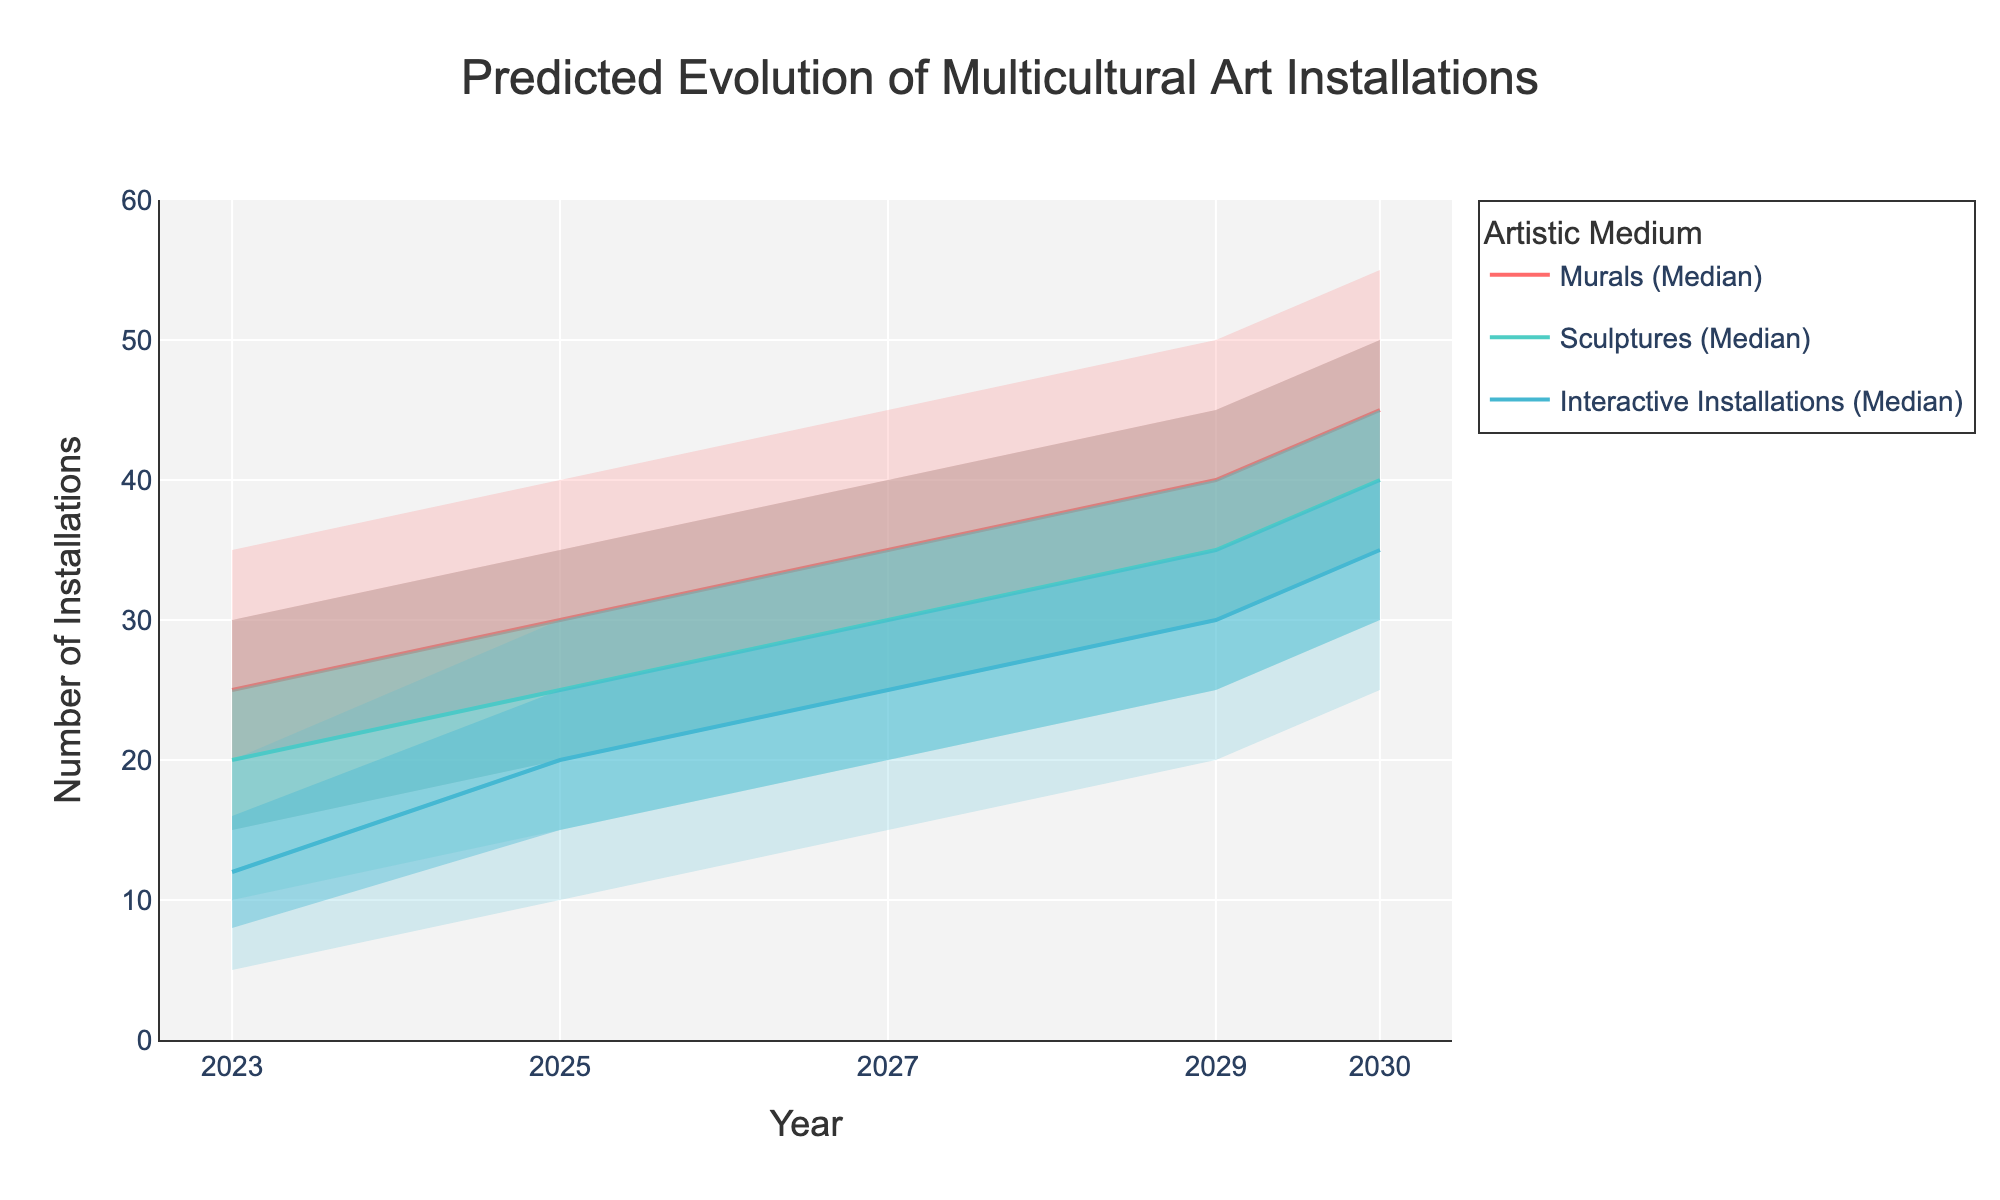What's the title of the figure? The title is usually located at the top of the figure. In this case, based on the provided code, we know the title is 'Predicted Evolution of Multicultural Art Installations.'
Answer: Predicted Evolution of Multicultural Art Installations Which medium shows the highest median number of installations in 2023? By looking at the median values for each medium in 2023, we see that Murals have a median of 25, Sculptures have 20, and Interactive Installations have 12. Thus, Murals have the highest median.
Answer: Murals What is the range of predicted installations for Sculptures in 2025? The range can be determined by subtracting the lower bound from the upper bound for Sculptures in 2025, which is 35 - 15.
Answer: 20 How do the upper quartile values of Murals and Sculptures compare in 2027? In 2027, the upper quartile for Murals is 40, and for Sculptures, it is 35. Therefore, the upper quartile for Murals is higher.
Answer: Murals have a higher upper quartile What is the expected increase in the median number of Interactive Installations from 2023 to 2030? The median number of installations for Interactive Installations in 2023 is 12 and in 2030 is 35. The increase is 35 - 12.
Answer: 23 Which medium has the widest interquartile range (IQR) in 2029? The IQR is calculated as the upper quartile minus the lower quartile. For Murals, it is 45 - 35 = 10; for Sculptures, it is 40 - 30 = 10; for Interactive Installations, it is 35 - 25 = 10. All three mediums have the same IQR.
Answer: All mediums have the same IQR Do the upper quartile ranges for Murals and Interactive Installations overlap in 2025? The upper quartile range for Murals in 2025 is between 30 and 35, and for Interactive Installations, it is between 15 and 25. These ranges do not overlap.
Answer: No What is the predicted median number of Sculptures in 2025, and how does it compare to the lower quartile of Murals in the same year? The median number of Sculptures in 2025 is 25. The lower quartile of Murals in 2025 is also 25. Both values are equal.
Answer: 25, equal Which medium is projected to have the smallest lower bound in 2030? In 2030, the lower bounds are 35 for Murals, 30 for Sculptures, and 25 for Interactive Installations. Therefore, Interactive Installations have the smallest lower bound.
Answer: Interactive Installations How does the predicted number of Interactive Installations change from 2023 to 2029 in terms of its upper bound? The upper bound for Interactive Installations is 20 in 2023 and 40 in 2029. The change is 40 - 20.
Answer: Increases by 20 